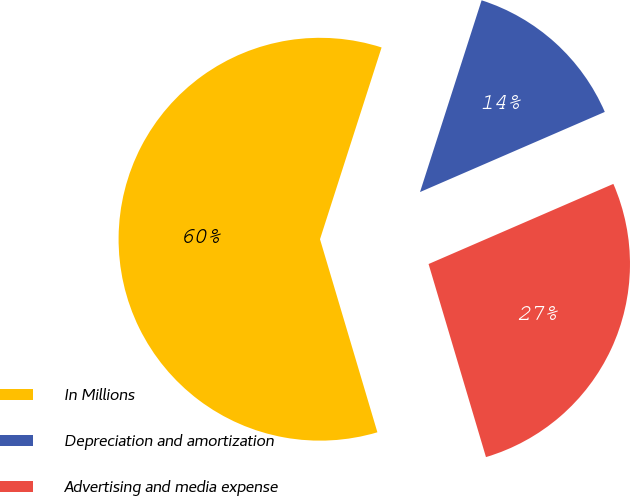Convert chart. <chart><loc_0><loc_0><loc_500><loc_500><pie_chart><fcel>In Millions<fcel>Depreciation and amortization<fcel>Advertising and media expense<nl><fcel>59.54%<fcel>13.54%<fcel>26.91%<nl></chart> 